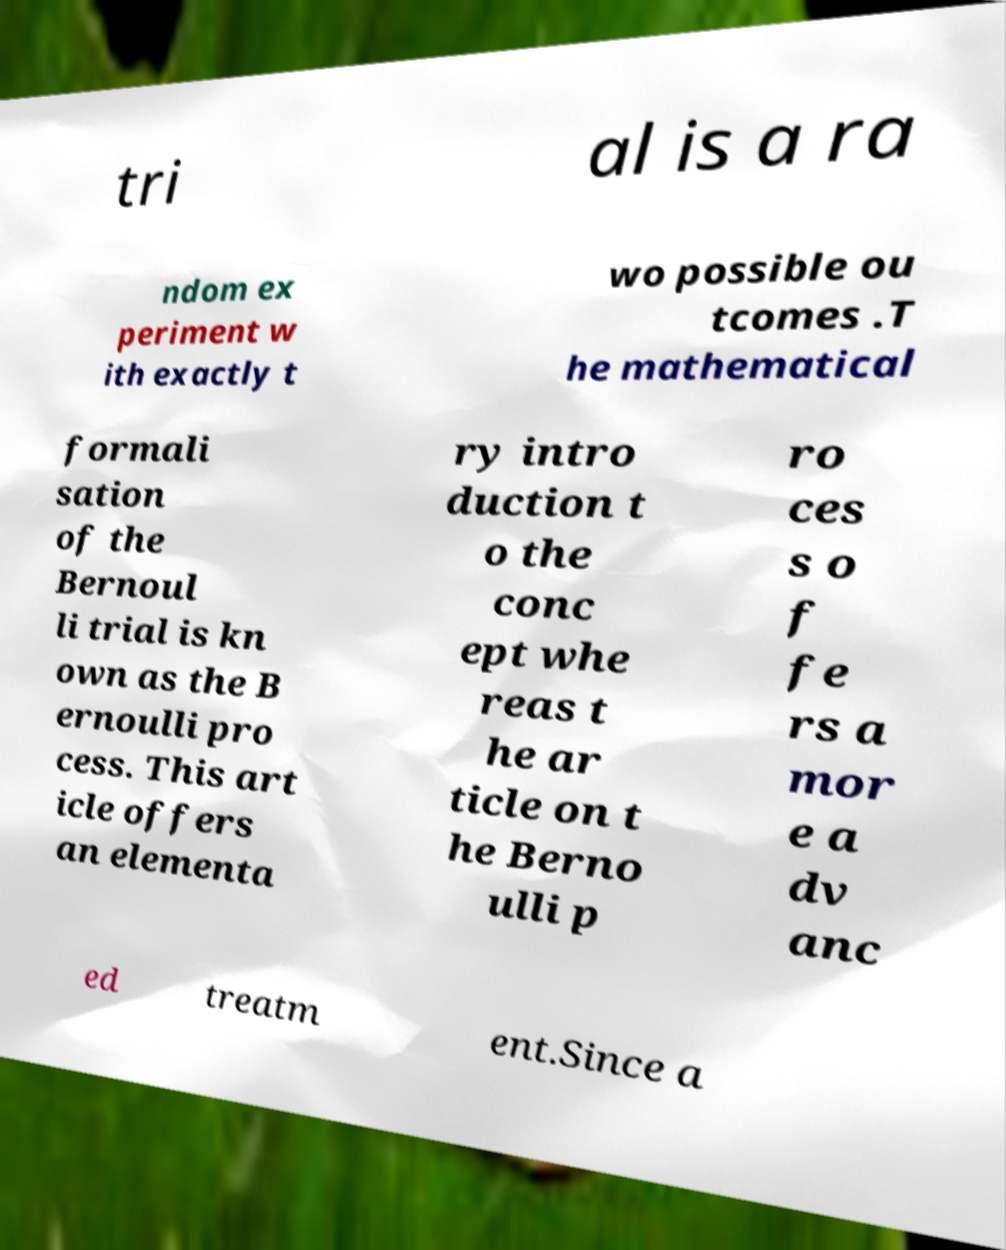Please identify and transcribe the text found in this image. tri al is a ra ndom ex periment w ith exactly t wo possible ou tcomes .T he mathematical formali sation of the Bernoul li trial is kn own as the B ernoulli pro cess. This art icle offers an elementa ry intro duction t o the conc ept whe reas t he ar ticle on t he Berno ulli p ro ces s o f fe rs a mor e a dv anc ed treatm ent.Since a 